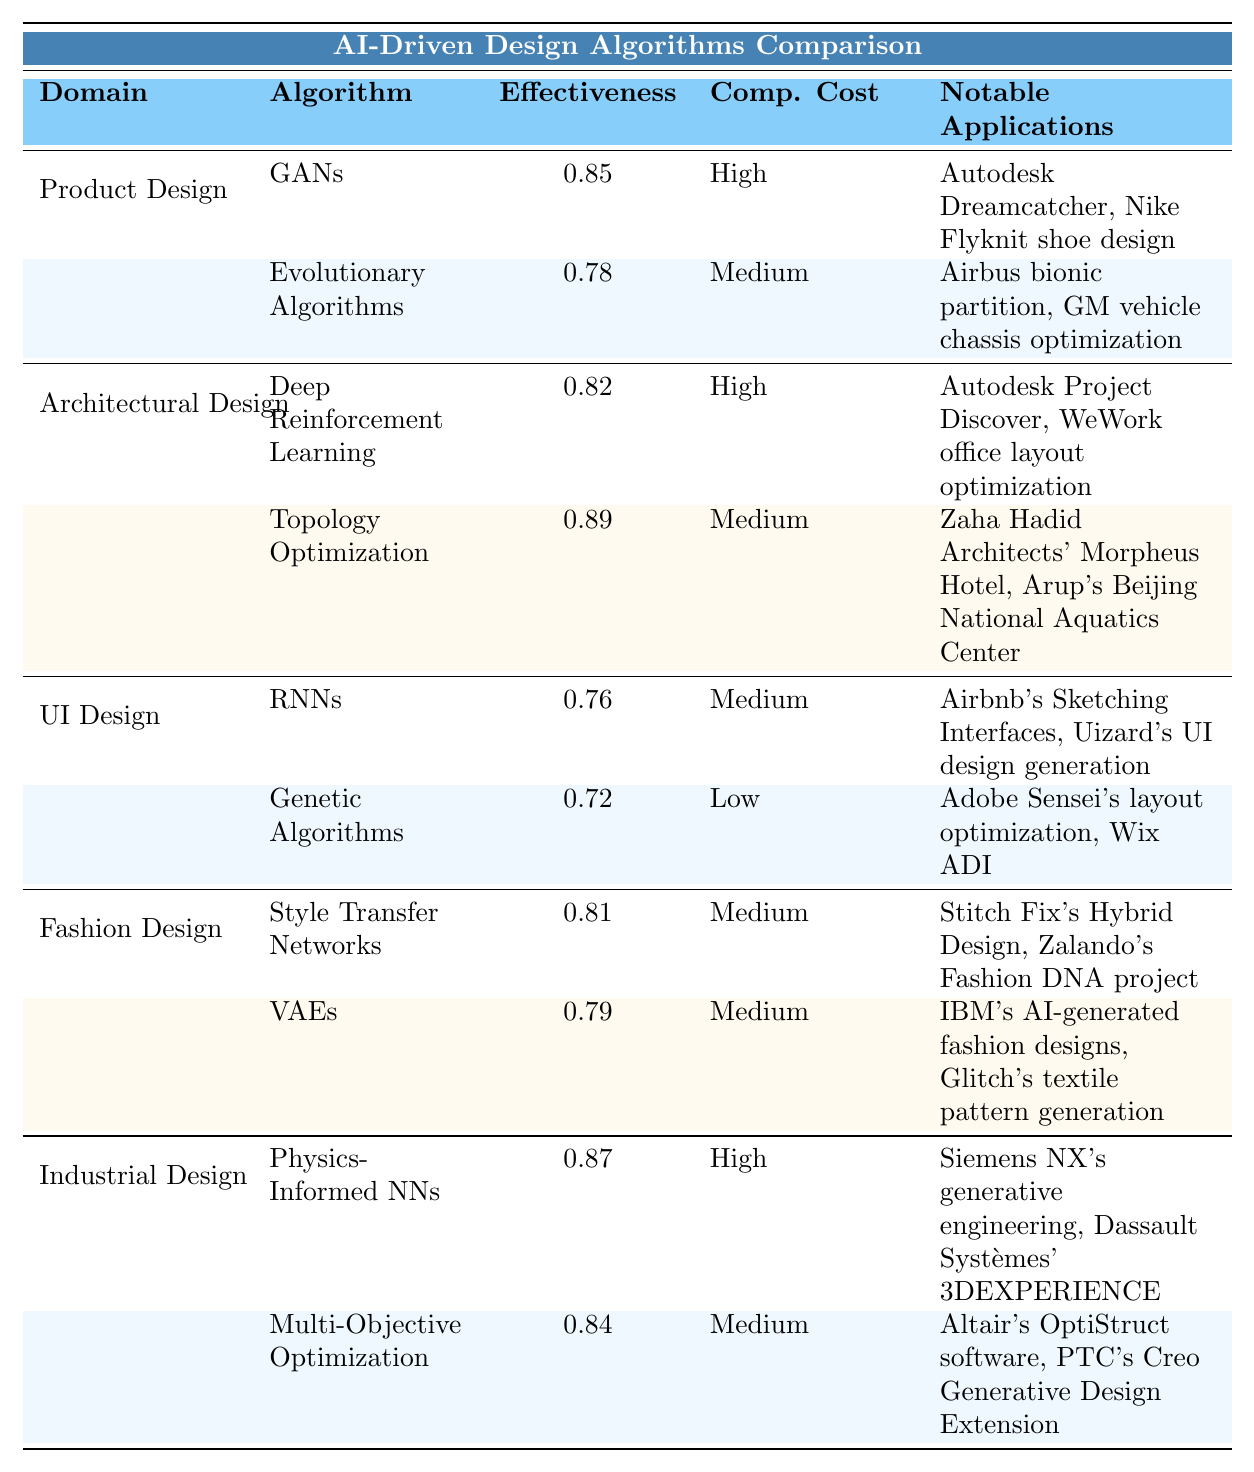What is the effectiveness of Topology Optimization in Architectural Design? The table lists the effectiveness of Topology Optimization under Architectural Design, which is 0.89.
Answer: 0.89 Which algorithm in Fashion Design has the lowest effectiveness? In the Fashion Design domain, the algorithm with the lowest effectiveness is Genetic Algorithms, which has an effectiveness of 0.72.
Answer: Genetic Algorithms What is the computational cost of Physics-Informed Neural Networks in Industrial Design? The table shows that the computational cost of Physics-Informed Neural Networks in Industrial Design is High.
Answer: High Which two algorithms in Product Design have effectiveness greater than 0.80? In the Product Design domain, only Generative Adversarial Networks (0.85) and Evolutionary Algorithms (0.78) are listed, but only GANs have an effectiveness greater than 0.80.
Answer: Generative Adversarial Networks Is the effectiveness of Style Transfer Networks in Fashion Design higher than that of Variational Autoencoders? The effectiveness of Style Transfer Networks is 0.81, while Variational Autoencoders is 0.79. Since 0.81 is greater than 0.79, the answer is yes.
Answer: Yes What is the average effectiveness of algorithms in User Interface Design? The two algorithms listed for UI Design are RNNs (0.76) and Genetic Algorithms (0.72). The average is (0.76 + 0.72) / 2 = 0.74.
Answer: 0.74 Which domain has the highest effectiveness algorithm and what is its name? In the table, the highest effectiveness value is 0.89, associated with the Topology Optimization algorithm in the Architectural Design domain.
Answer: Topology Optimization How many algorithms in Industrial Design have low computational cost? The table lists two algorithms under Industrial Design, but both are High and Medium cost, indicating there are no low computational cost algorithms in this domain.
Answer: 0 Which domain's algorithm has the highest computational cost among them all? By comparing the computational costs across domains, Physics-Informed Neural Networks and Deep Reinforcement Learning both have a High computational cost, but only the former has a higher effectiveness (0.87 vs. 0.82).
Answer: Industrial Design (Physics-Informed Neural Networks) Are there any algorithms in User Interface Design with Medium computational cost? Indeed, RNNs is listed with Medium computational cost in the User Interface Design section of the table.
Answer: Yes 